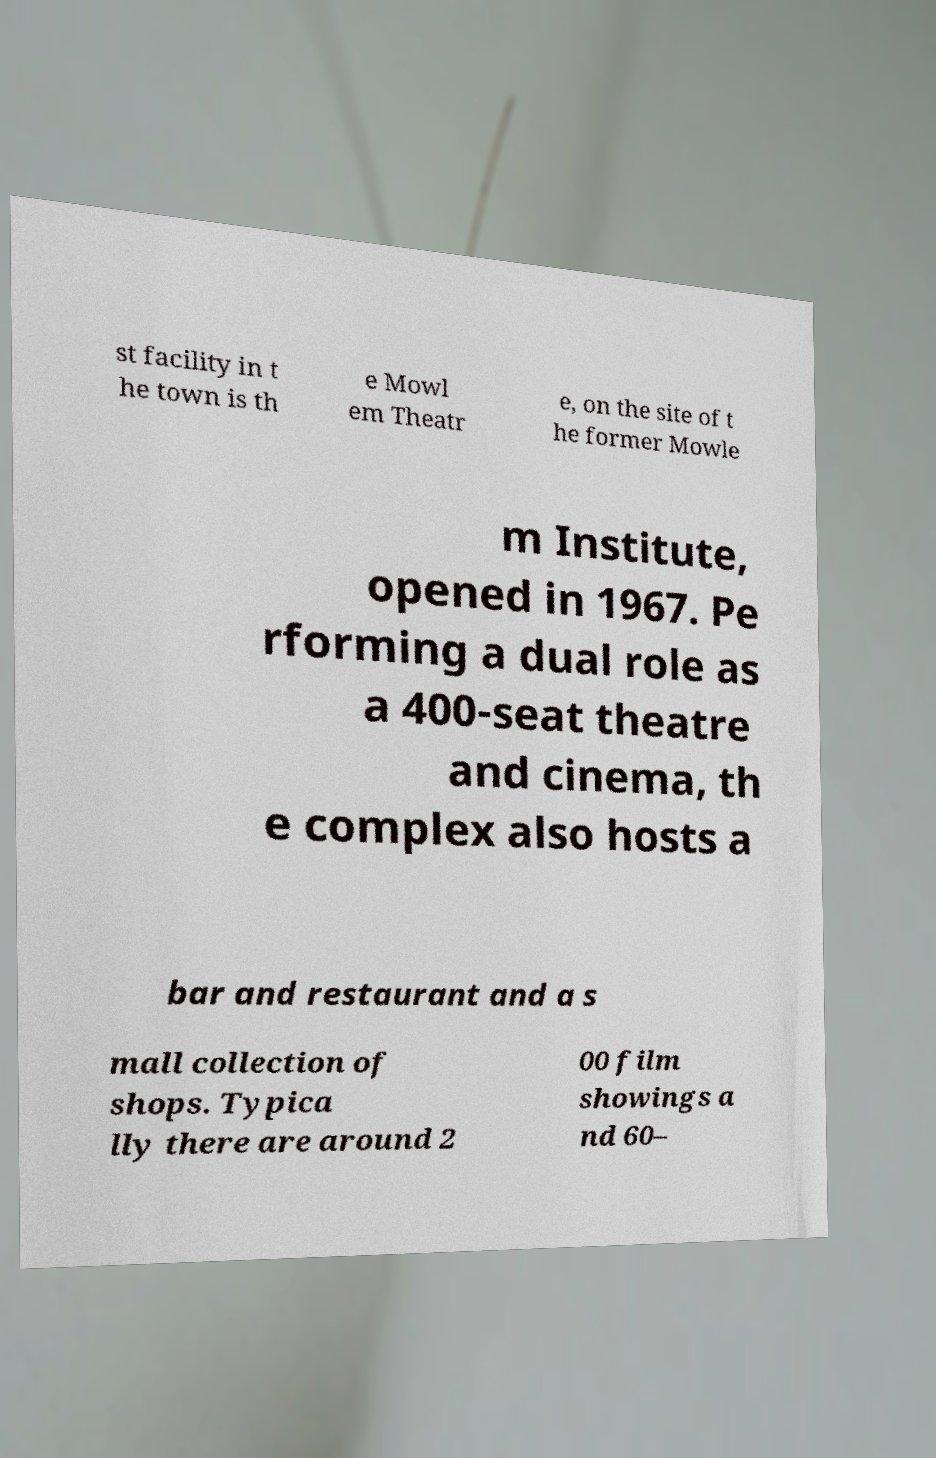For documentation purposes, I need the text within this image transcribed. Could you provide that? st facility in t he town is th e Mowl em Theatr e, on the site of t he former Mowle m Institute, opened in 1967. Pe rforming a dual role as a 400-seat theatre and cinema, th e complex also hosts a bar and restaurant and a s mall collection of shops. Typica lly there are around 2 00 film showings a nd 60– 